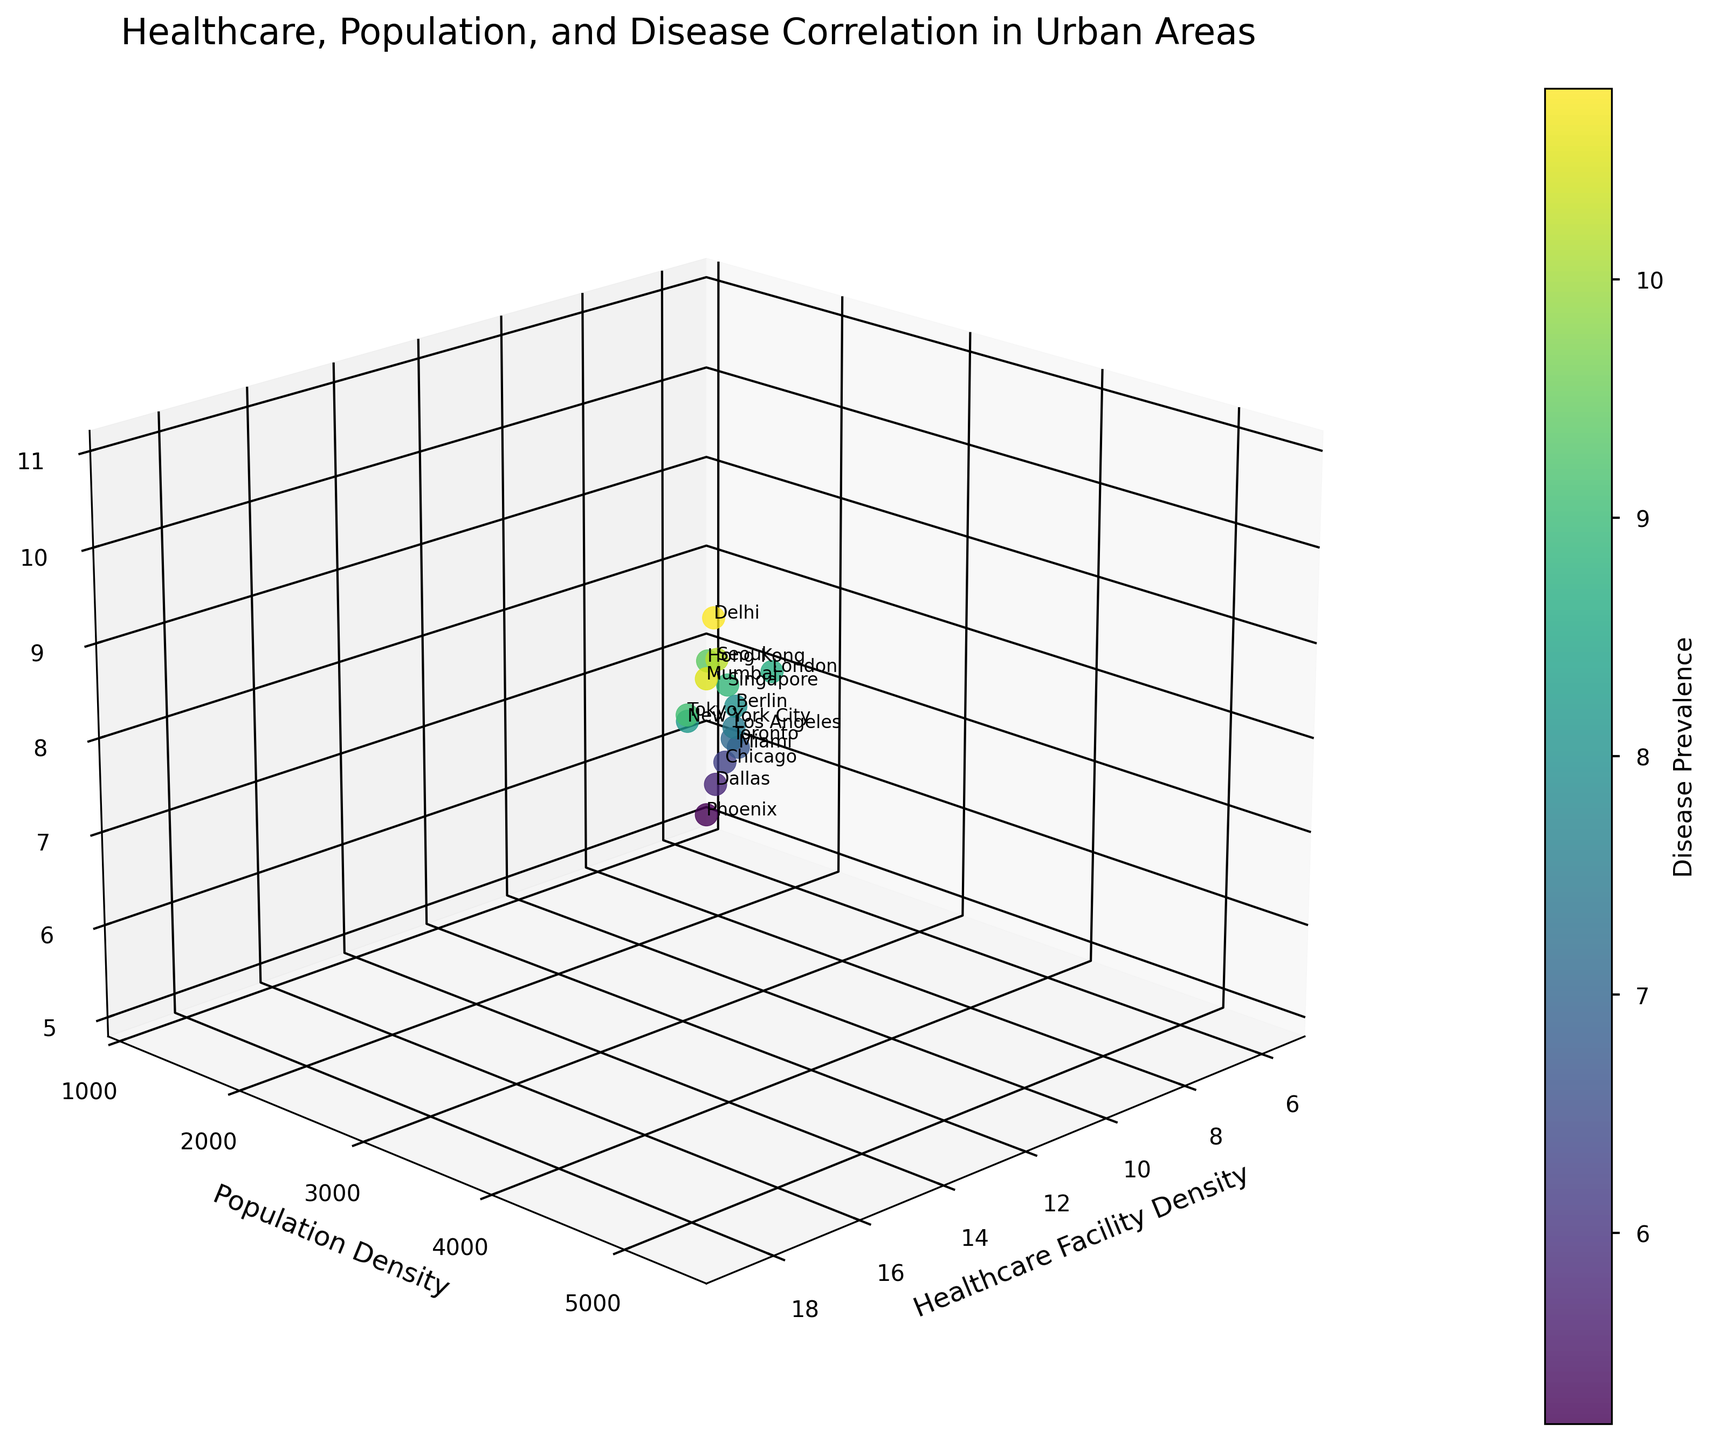How many cities are represented in the plot? Count the number of unique data points, each representing a city, and find the total. There are 15 cities listed in the data.
Answer: 15 What is the title of the figure? The title is displayed at the top of the plot. It reads "Healthcare, Population, and Disease Correlation in Urban Areas".
Answer: Healthcare, Population, and Disease Correlation in Urban Areas Which city has the highest disease prevalence? Locate the data point with the highest value on the disease prevalence axis. Delhi has the highest disease prevalence with a value of 10.8.
Answer: Delhi Which city has the lowest population density? Locate the data point with the lowest value on the population density axis. Phoenix has the lowest population density with a value of 1200.
Answer: Phoenix What is the average healthcare facility density for New York City and London? Identify the healthcare facility density values for New York City (12.5) and London (11.4). Calculate the average: (12.5 + 11.4) / 2 = 11.95.
Answer: 11.95 Is there a general trend between population density and disease prevalence? Observe the plot to identify any patterns or trends between the two axes. As population density increases, disease prevalence generally seems to increase as well.
Answer: Yes, they generally increase together Which city has a higher healthcare facility density: Seoul or Mumbai? Compare the healthcare facility density values for Seoul (16.8) and Mumbai (18.6). Mumbai has a higher value.
Answer: Mumbai What's the combined population density of Dallas and Miami? Add the population densities of Dallas (1500) and Miami (2100). 1500 + 2100 = 3600.
Answer: 3600 What are the labels on the three axes? Read the axis labels. The x-axis is "Healthcare Facility Density," the y-axis is "Population Density," and the z-axis is "Disease Prevalence."
Answer: Healthcare Facility Density, Population Density, Disease Prevalence For the city with the highest healthcare facility density, what is its disease prevalence? Identify the city with the highest healthcare facility density (Mumbai with 18.6) and find its disease prevalence, which is 10.5.
Answer: 10.5 